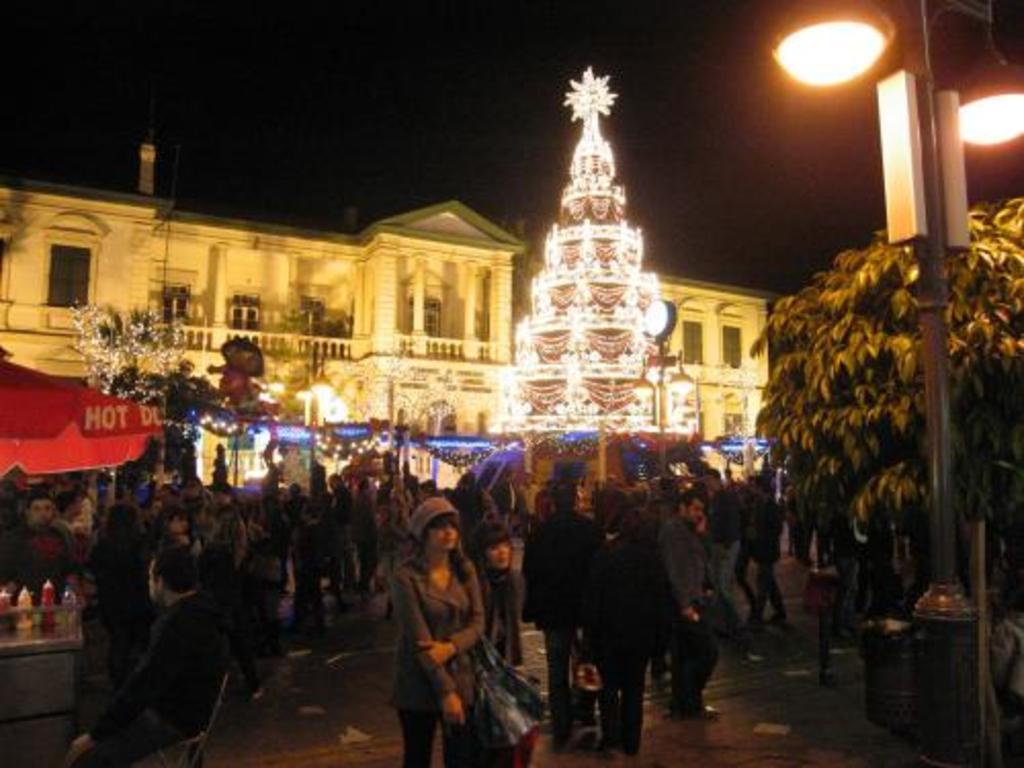Could you give a brief overview of what you see in this image? In the given image i can see a building,lights,plants,people,decorative objects,food stall and some other objects. 